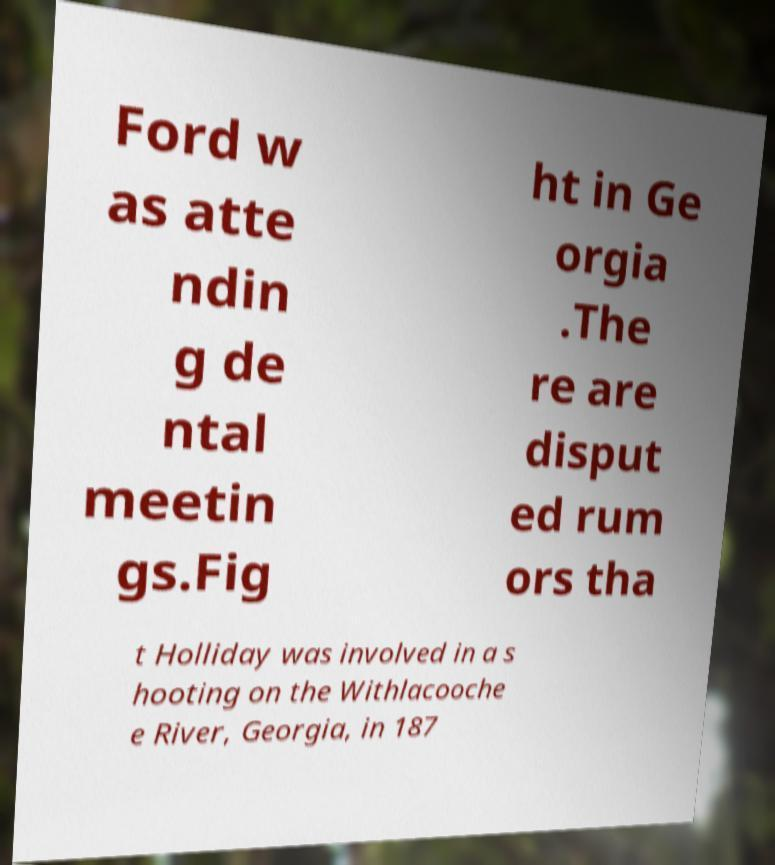Can you read and provide the text displayed in the image?This photo seems to have some interesting text. Can you extract and type it out for me? Ford w as atte ndin g de ntal meetin gs.Fig ht in Ge orgia .The re are disput ed rum ors tha t Holliday was involved in a s hooting on the Withlacooche e River, Georgia, in 187 